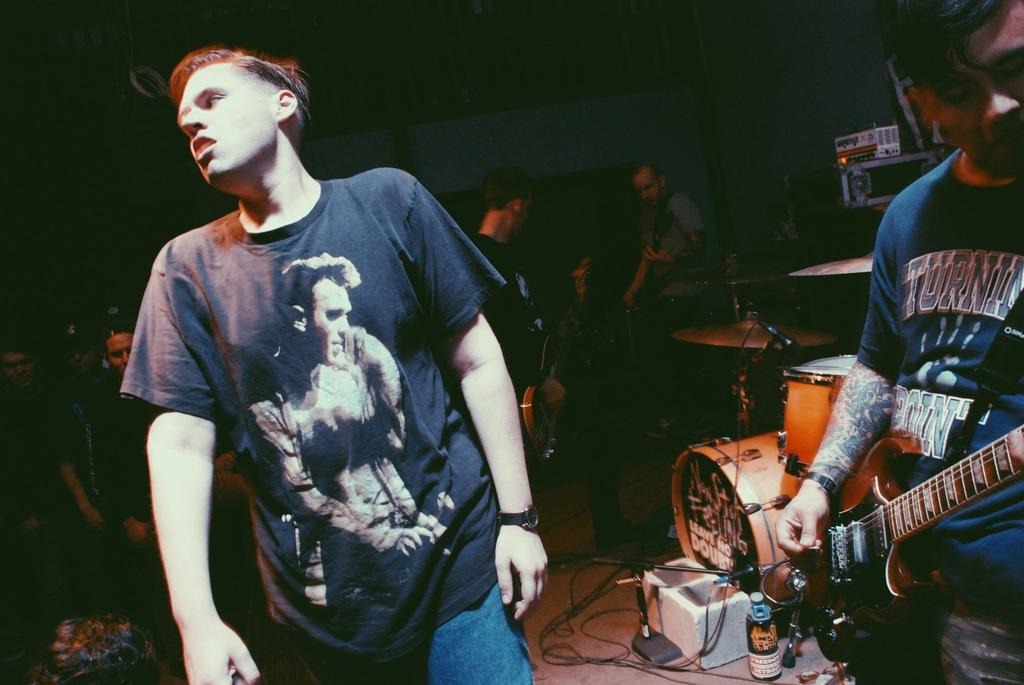Who or what can be seen in the image? There are people in the image. What are the people doing in the image? The people are performing. What specific activity are the people engaged in while performing? The people are playing musical instruments. What type of wood is being used to construct the development in the image? There is no development or construction site present in the image; it features people playing musical instruments. 